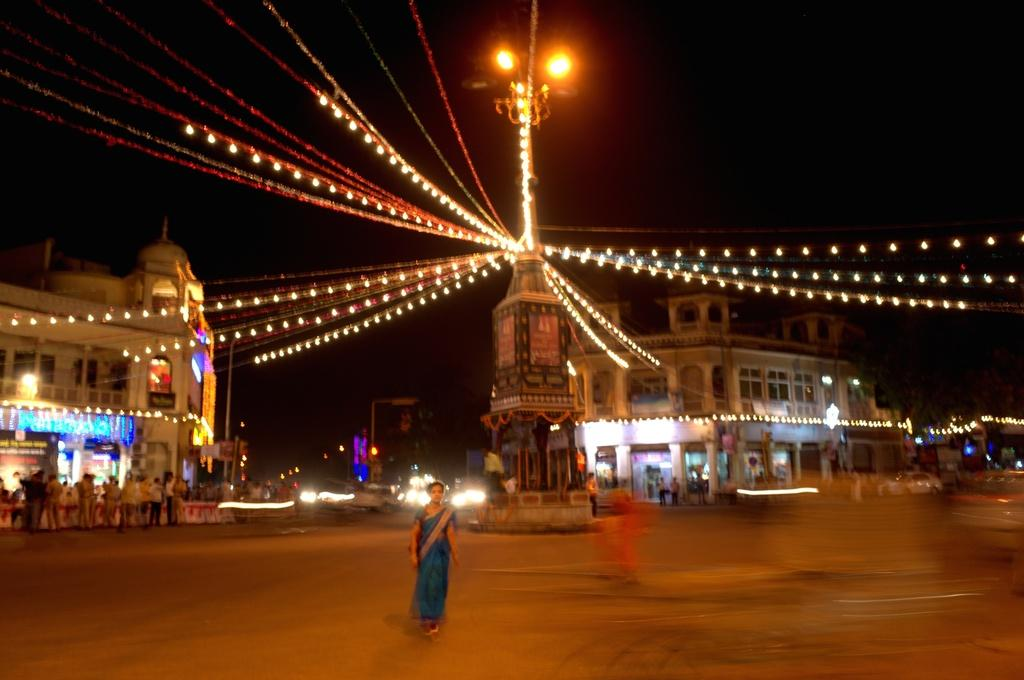What type of structures can be seen in the image? There are buildings in the image. What is the woman in the image doing? A woman is walking on the road in the image. What can be seen illuminating the scene in the image? There are lights in the image. What part of the natural environment is visible in the image? The sky is visible in the image. What is the name of the pump used by the woman in the image? There is no pump present in the image, and the woman's name is not mentioned. What type of line is visible in the image? There is no line visible in the image; it features buildings, a woman walking, lights, and the sky. 